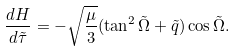<formula> <loc_0><loc_0><loc_500><loc_500>\frac { d H } { d \tilde { \tau } } = - \sqrt { \frac { \mu } { 3 } } ( \tan ^ { 2 } \tilde { \Omega } + \tilde { q } ) \cos \tilde { \Omega } .</formula> 